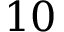Convert formula to latex. <formula><loc_0><loc_0><loc_500><loc_500>1 0</formula> 